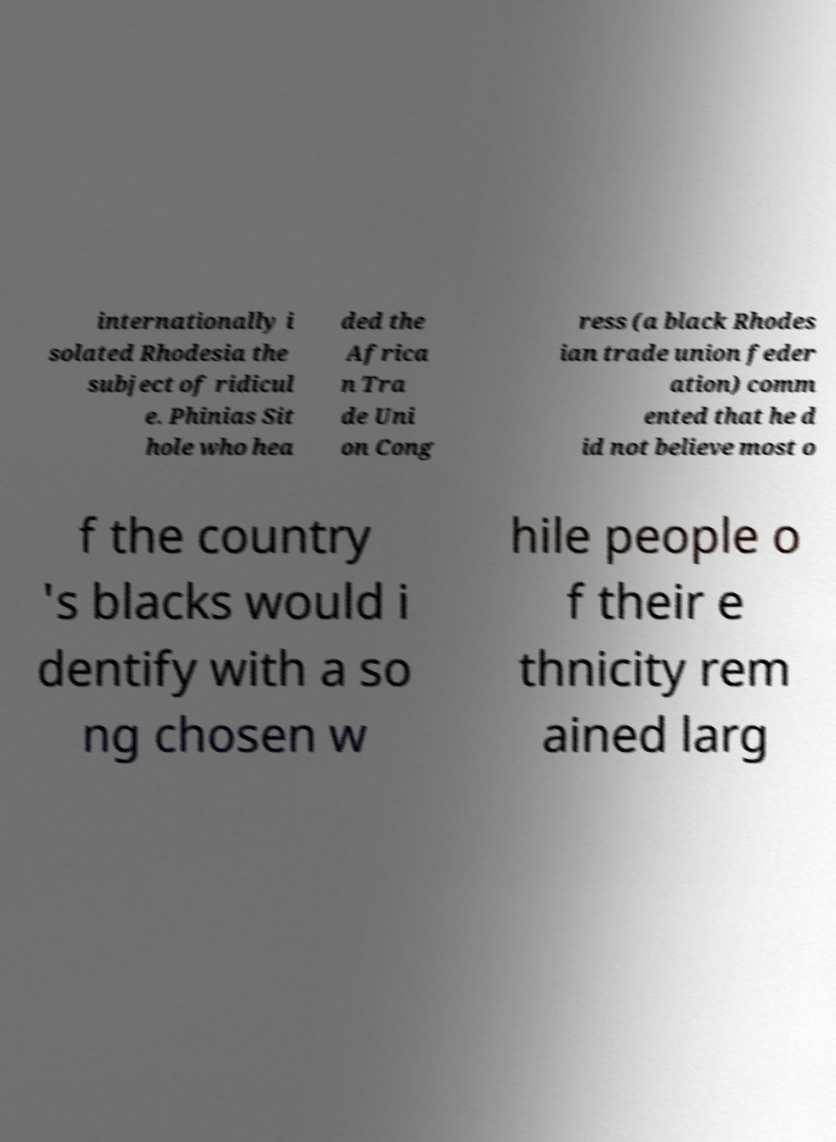Could you extract and type out the text from this image? internationally i solated Rhodesia the subject of ridicul e. Phinias Sit hole who hea ded the Africa n Tra de Uni on Cong ress (a black Rhodes ian trade union feder ation) comm ented that he d id not believe most o f the country 's blacks would i dentify with a so ng chosen w hile people o f their e thnicity rem ained larg 